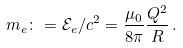Convert formula to latex. <formula><loc_0><loc_0><loc_500><loc_500>m _ { e } \colon = \mathcal { E } _ { e } / c ^ { 2 } = \frac { \mu _ { 0 } } { 8 \pi } \frac { Q ^ { 2 } } { R } \, .</formula> 